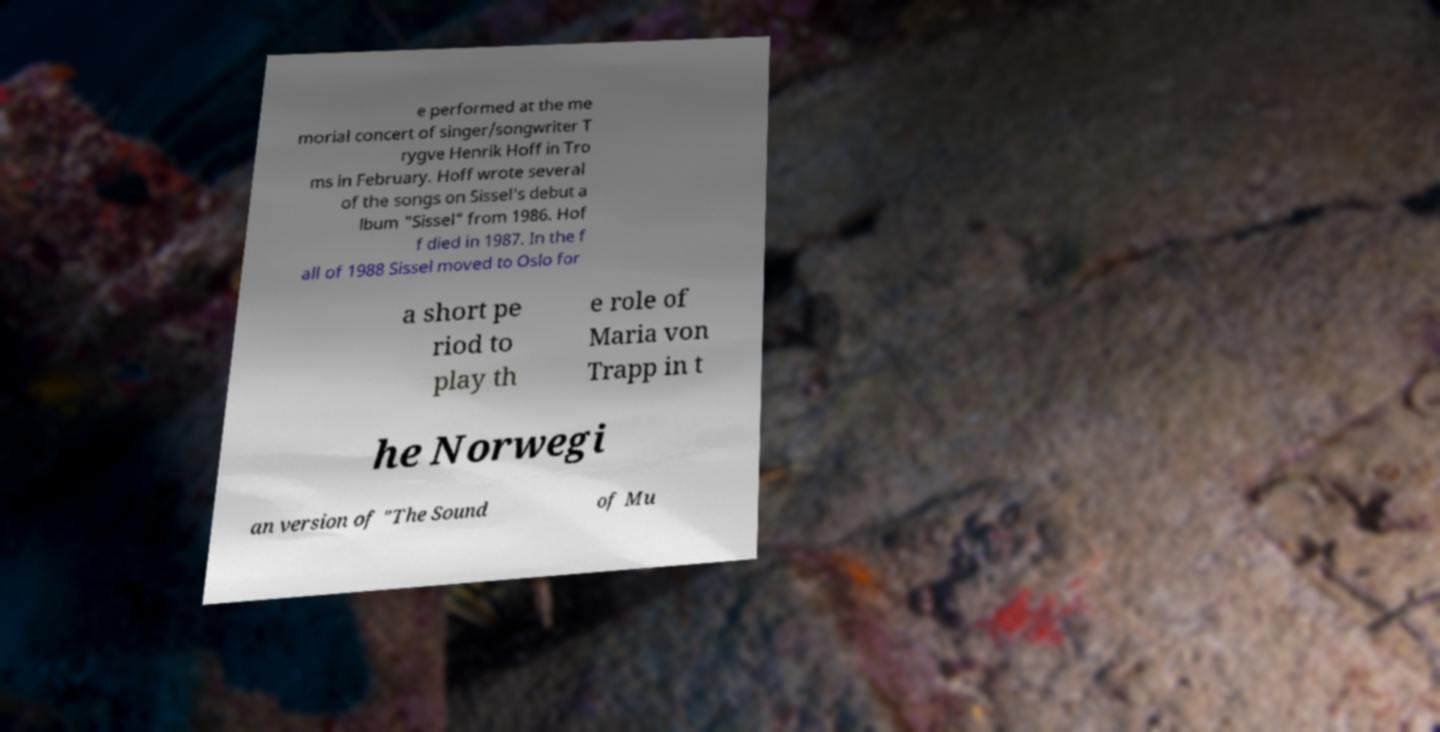What messages or text are displayed in this image? I need them in a readable, typed format. e performed at the me morial concert of singer/songwriter T rygve Henrik Hoff in Tro ms in February. Hoff wrote several of the songs on Sissel's debut a lbum "Sissel" from 1986. Hof f died in 1987. In the f all of 1988 Sissel moved to Oslo for a short pe riod to play th e role of Maria von Trapp in t he Norwegi an version of "The Sound of Mu 